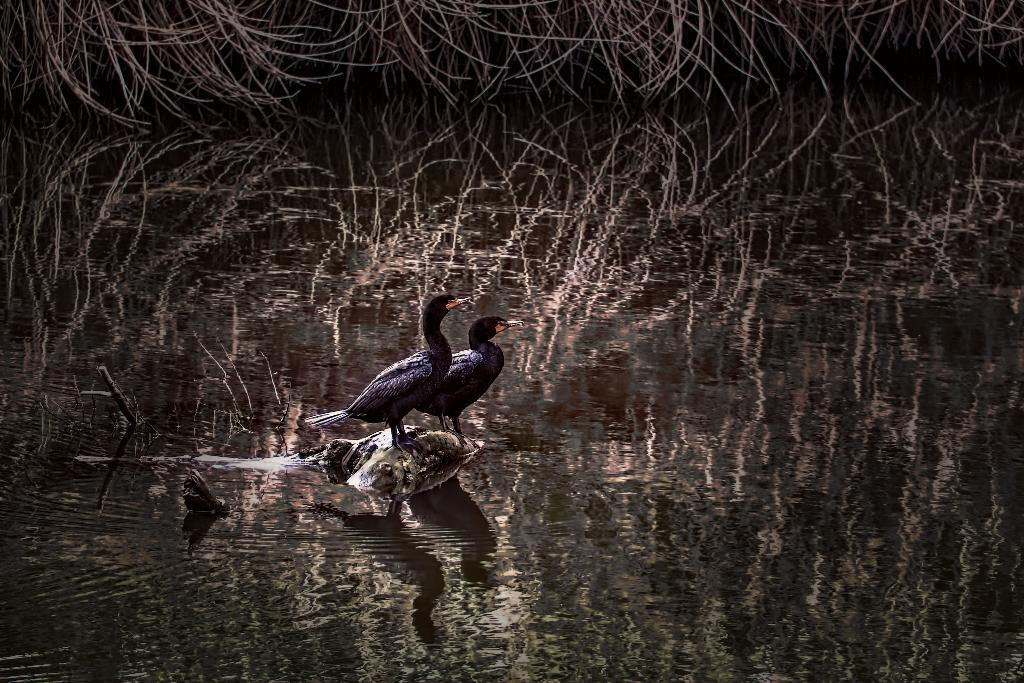How many birds are present in the image? There are two birds in the image. What is the primary element in which the birds are situated? The birds are situated in water. What can be seen in the background of the image? There are trees in the background of the image. What kind of adjustment does the stranger need to make in order to join the birds in the image? There is no stranger present in the image, so no adjustment is necessary. 